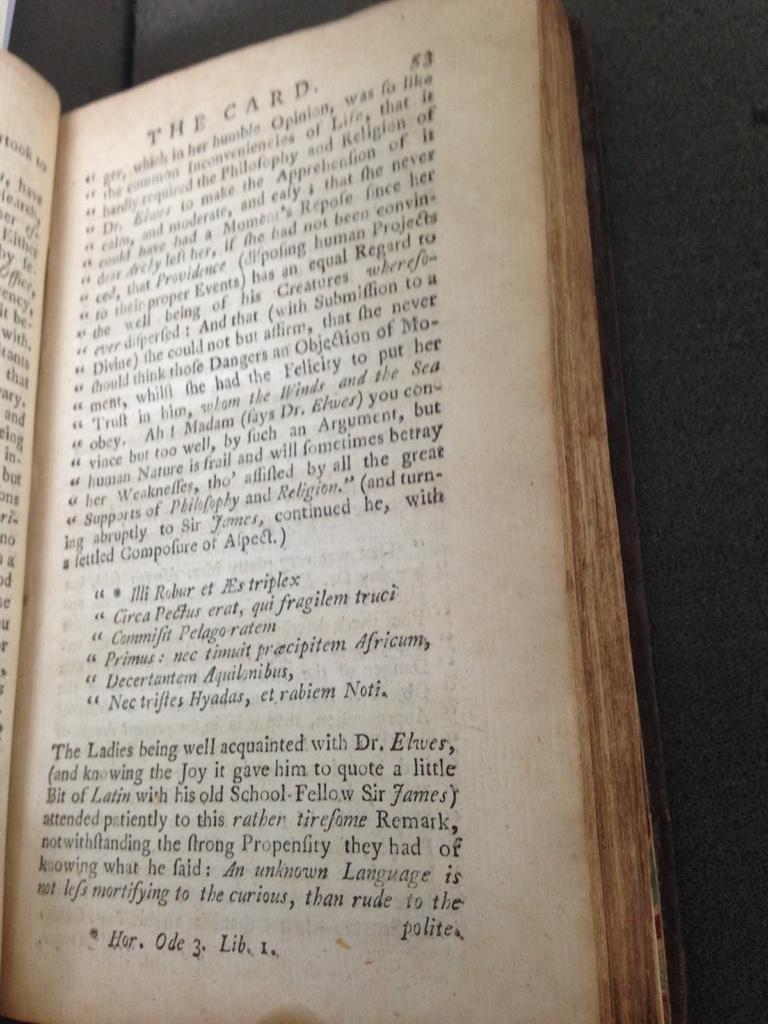<image>
Summarize the visual content of the image. A book titled "The Card" that is on page 53. 